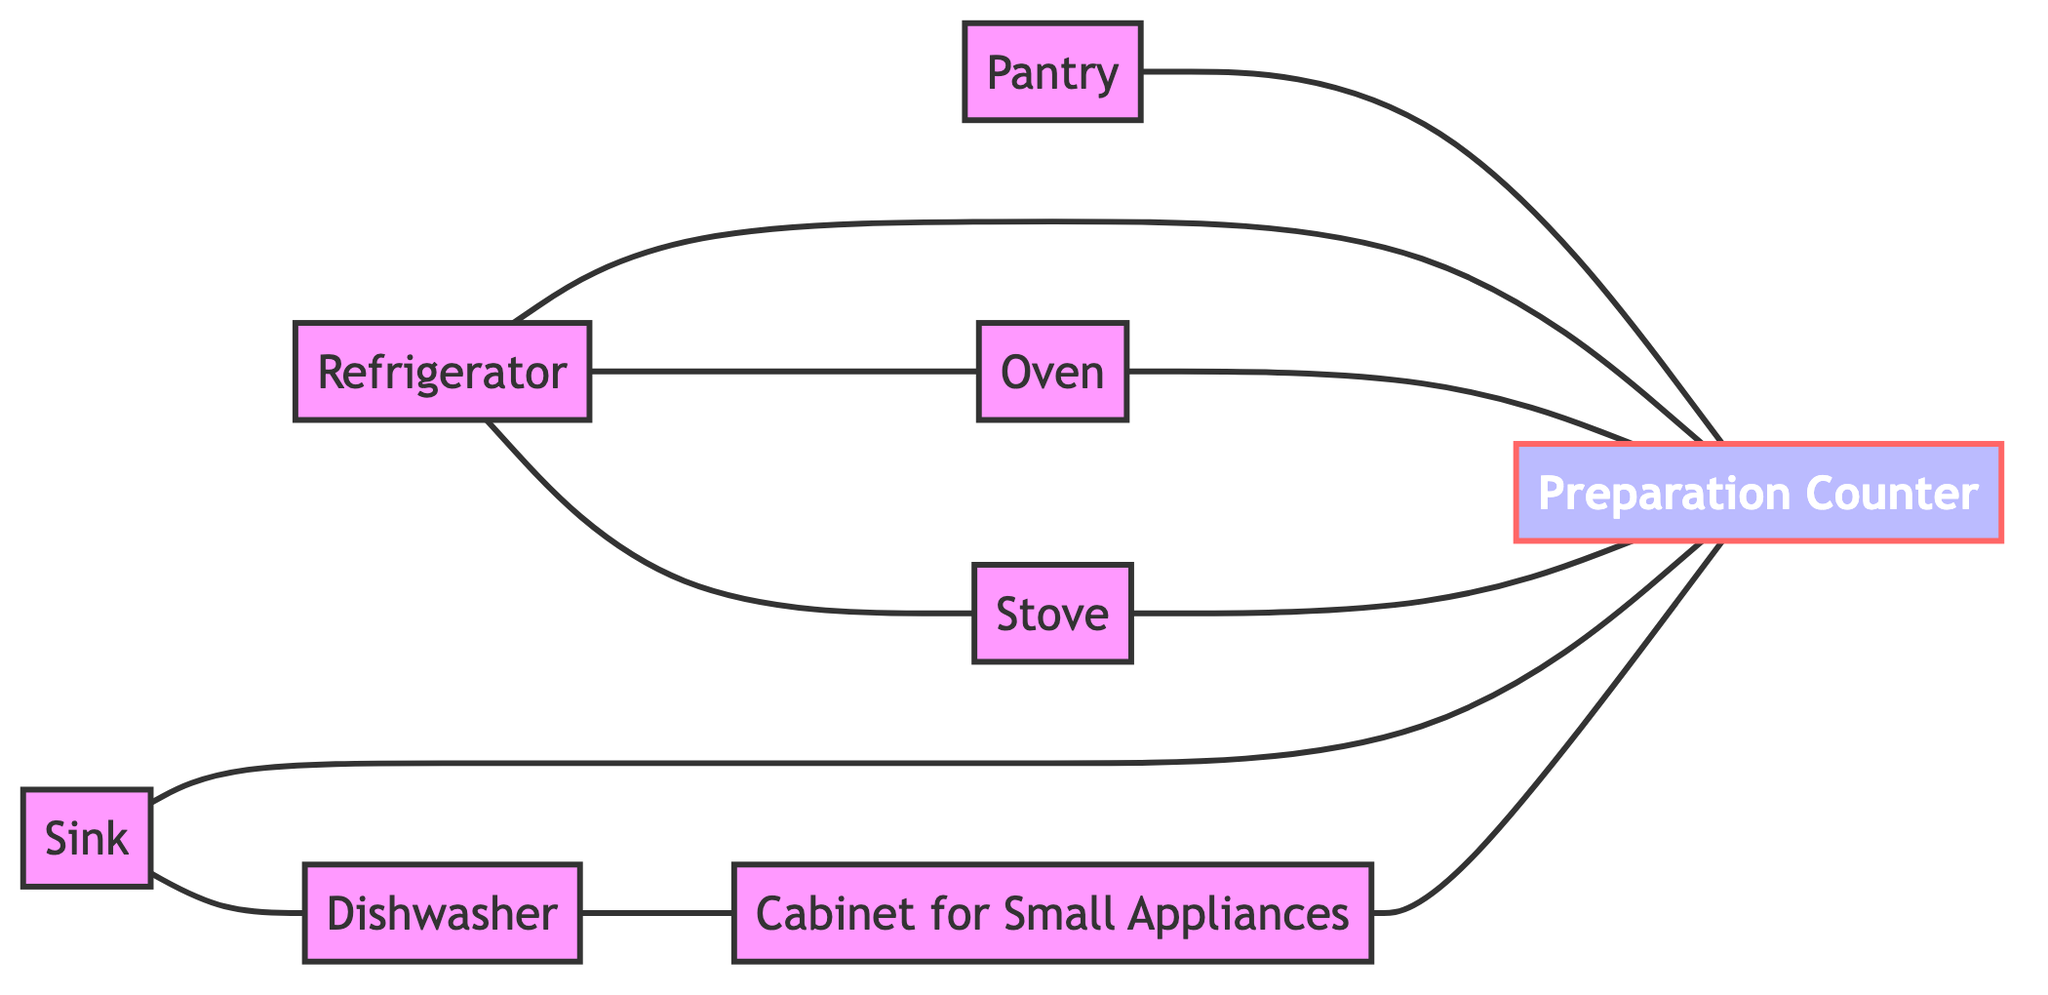What are the main storage areas in the diagram? The main storage areas are the pantry and the cabinet for small appliances. These are identified as nodes that specifically represent storage areas within the kitchen layout.
Answer: pantry, cabinet for small appliances How many total nodes are present in the diagram? By counting all the distinct nodes listed in the data, we find there are a total of 8 nodes: pantry, refrigerator, oven, stove, sink, dishwasher, prepCounter, and cabinetSmallAppliances.
Answer: 8 Which appliance is directly connected to the sink? Upon examining the edges connected to the sink node, the only direct connection is to the dishwasher, as indicated by the edge from sink to dishwasher.
Answer: Dishwasher What is the relationship between the refrigerator and the oven? The diagram shows a direct edge connecting the refrigerator to the oven, indicating that these two appliances are interrelated and easily accessible to each other.
Answer: Refrigerator to Oven Which areas connect directly to the preparation counter? The prep counter is connected to multiple areas: the pantry, refrigerator, oven, stove, and sink, as indicated by the direct edges leading into the prep counter.
Answer: Pantry, Refrigerator, Oven, Stove, Sink How many edges connect to the preparation counter? Counting the edges leading into the prep counter, we find there are 5 edges: one from the pantry, one from the refrigerator, one from the oven, one from the stove, and one from the sink.
Answer: 5 Which cabinet is linked to the dishwasher? The dishwasher has a direct edge connecting it to the cabinet for small appliances, indicating that they are linked in the kitchen layout for functionality.
Answer: Cabinet for Small Appliances Which appliance has no direct connection to the cabinet for small appliances? Upon reviewing the connections, the oven does not have any direct edge leading to the cabinet for small appliances, making it the appliance that is not directly connected to this storage area.
Answer: Oven What is the main function of the preparation counter as indicated by the diagram? The preparation counter serves as a central hub, connected to various storage areas and appliances, indicating its role for food preparation and workflow optimization in the kitchen.
Answer: Central hub for preparation 